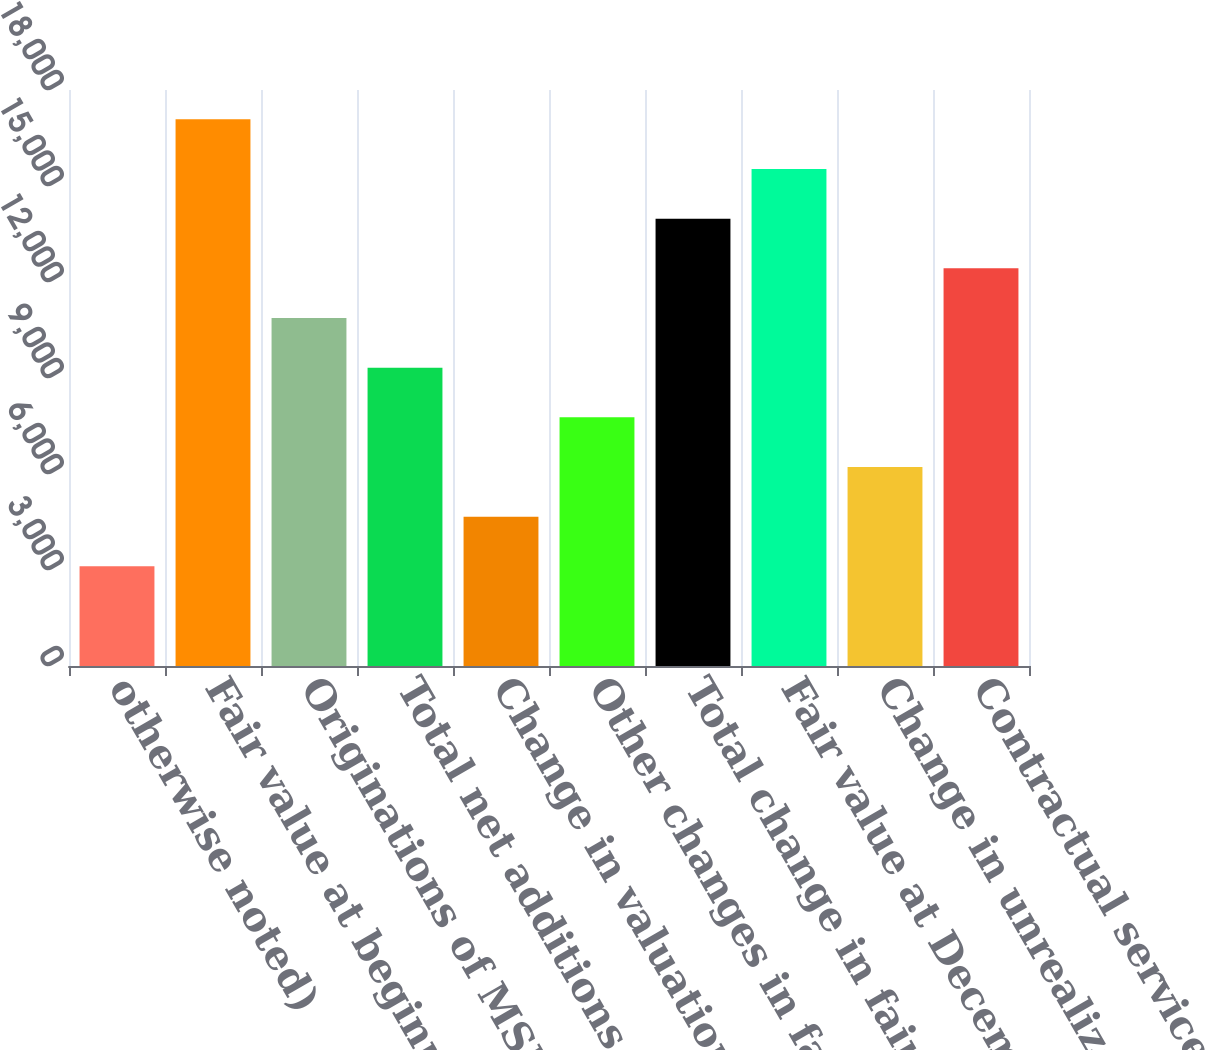Convert chart to OTSL. <chart><loc_0><loc_0><loc_500><loc_500><bar_chart><fcel>otherwise noted)<fcel>Fair value at beginning of<fcel>Originations of MSRs<fcel>Total net additions<fcel>Change in valuation due to<fcel>Other changes in fair value<fcel>Total change in fair value of<fcel>Fair value at December 31 (d)<fcel>Change in unrealized gains/<fcel>Contractual service fees late<nl><fcel>3114.12<fcel>17083.1<fcel>10874.7<fcel>9322.56<fcel>4666.23<fcel>7770.45<fcel>13978.9<fcel>15531<fcel>6218.34<fcel>12426.8<nl></chart> 